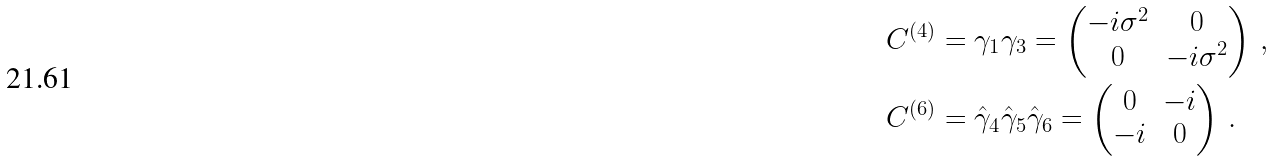Convert formula to latex. <formula><loc_0><loc_0><loc_500><loc_500>C ^ { ( 4 ) } & = \gamma _ { 1 } \gamma _ { 3 } = \begin{pmatrix} - i \sigma ^ { 2 } & 0 \\ 0 & - i \sigma ^ { 2 } \end{pmatrix} \, , \\ C ^ { ( 6 ) } & = \hat { \gamma } _ { 4 } \hat { \gamma } _ { 5 } \hat { \gamma } _ { 6 } = \begin{pmatrix} 0 & - i \\ - i & 0 \end{pmatrix} \, .</formula> 